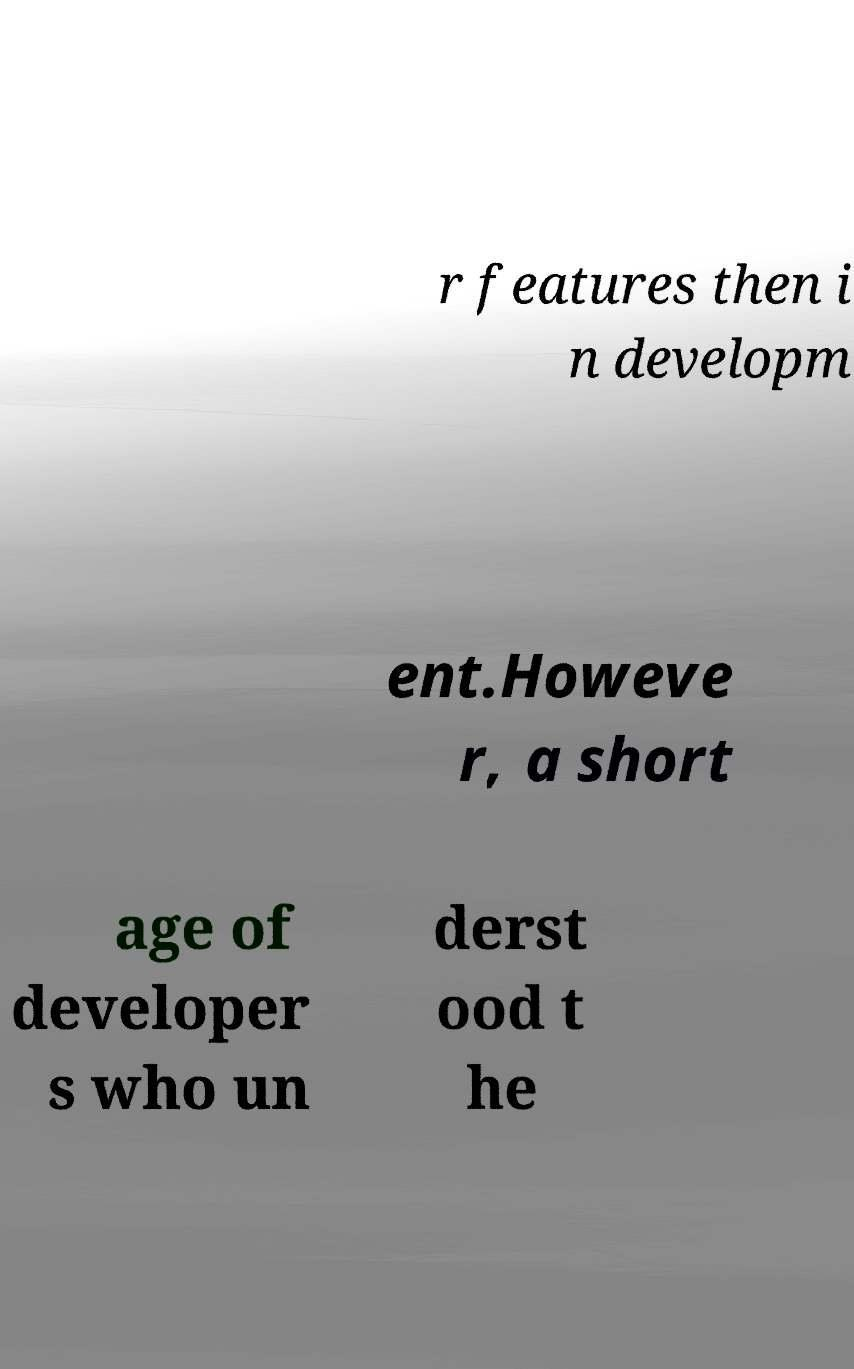Please read and relay the text visible in this image. What does it say? r features then i n developm ent.Howeve r, a short age of developer s who un derst ood t he 